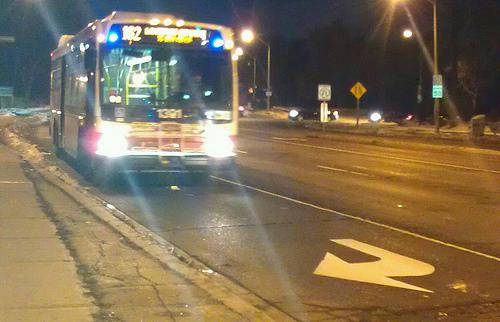Question: what is photographed?
Choices:
A. A car.
B. A truck.
C. A bus.
D. A minivan.
Answer with the letter. Answer: C Question: what is painted on the street?
Choices:
A. Stripes.
B. A crosswalk.
C. Numbers.
D. Right turn arrow.
Answer with the letter. Answer: D Question: where was this photo taken?
Choices:
A. In a city.
B. At the beach.
C. In a diner.
D. At the door.
Answer with the letter. Answer: A Question: where is the bus?
Choices:
A. In the left lane.
B. In a field.
C. In the air.
D. In the right turn lane.
Answer with the letter. Answer: D Question: why is there glare on the photo?
Choices:
A. Candle light.
B. Headlights reflecting.
C. Sun light.
D. Light fixtures.
Answer with the letter. Answer: B 